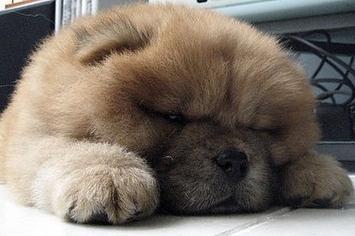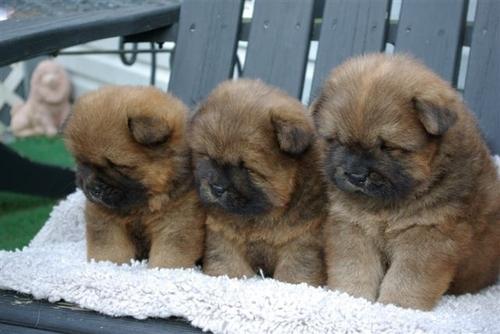The first image is the image on the left, the second image is the image on the right. Examine the images to the left and right. Is the description "One of the images features a dog laying down." accurate? Answer yes or no. Yes. The first image is the image on the left, the second image is the image on the right. Evaluate the accuracy of this statement regarding the images: "Each image contains exactly one chow pup, and the pup that has darker, non-blond fur is standing on all fours.". Is it true? Answer yes or no. No. 